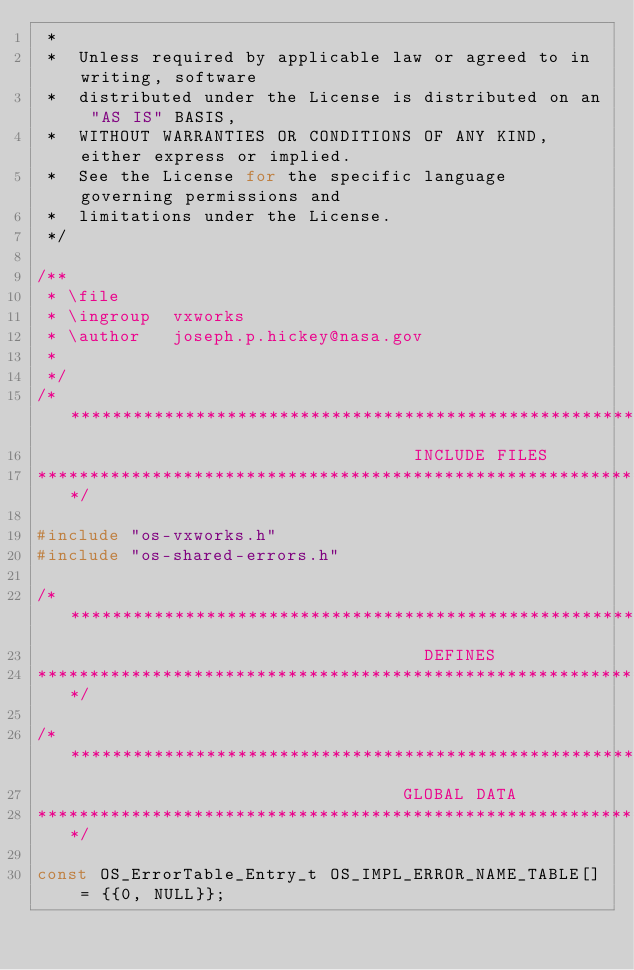Convert code to text. <code><loc_0><loc_0><loc_500><loc_500><_C_> *
 *  Unless required by applicable law or agreed to in writing, software
 *  distributed under the License is distributed on an "AS IS" BASIS,
 *  WITHOUT WARRANTIES OR CONDITIONS OF ANY KIND, either express or implied.
 *  See the License for the specific language governing permissions and
 *  limitations under the License.
 */

/**
 * \file
 * \ingroup  vxworks
 * \author   joseph.p.hickey@nasa.gov
 *
 */
/****************************************************************************************
                                    INCLUDE FILES
****************************************************************************************/

#include "os-vxworks.h"
#include "os-shared-errors.h"

/****************************************************************************************
                                     DEFINES
****************************************************************************************/

/****************************************************************************************
                                   GLOBAL DATA
****************************************************************************************/

const OS_ErrorTable_Entry_t OS_IMPL_ERROR_NAME_TABLE[] = {{0, NULL}};
</code> 